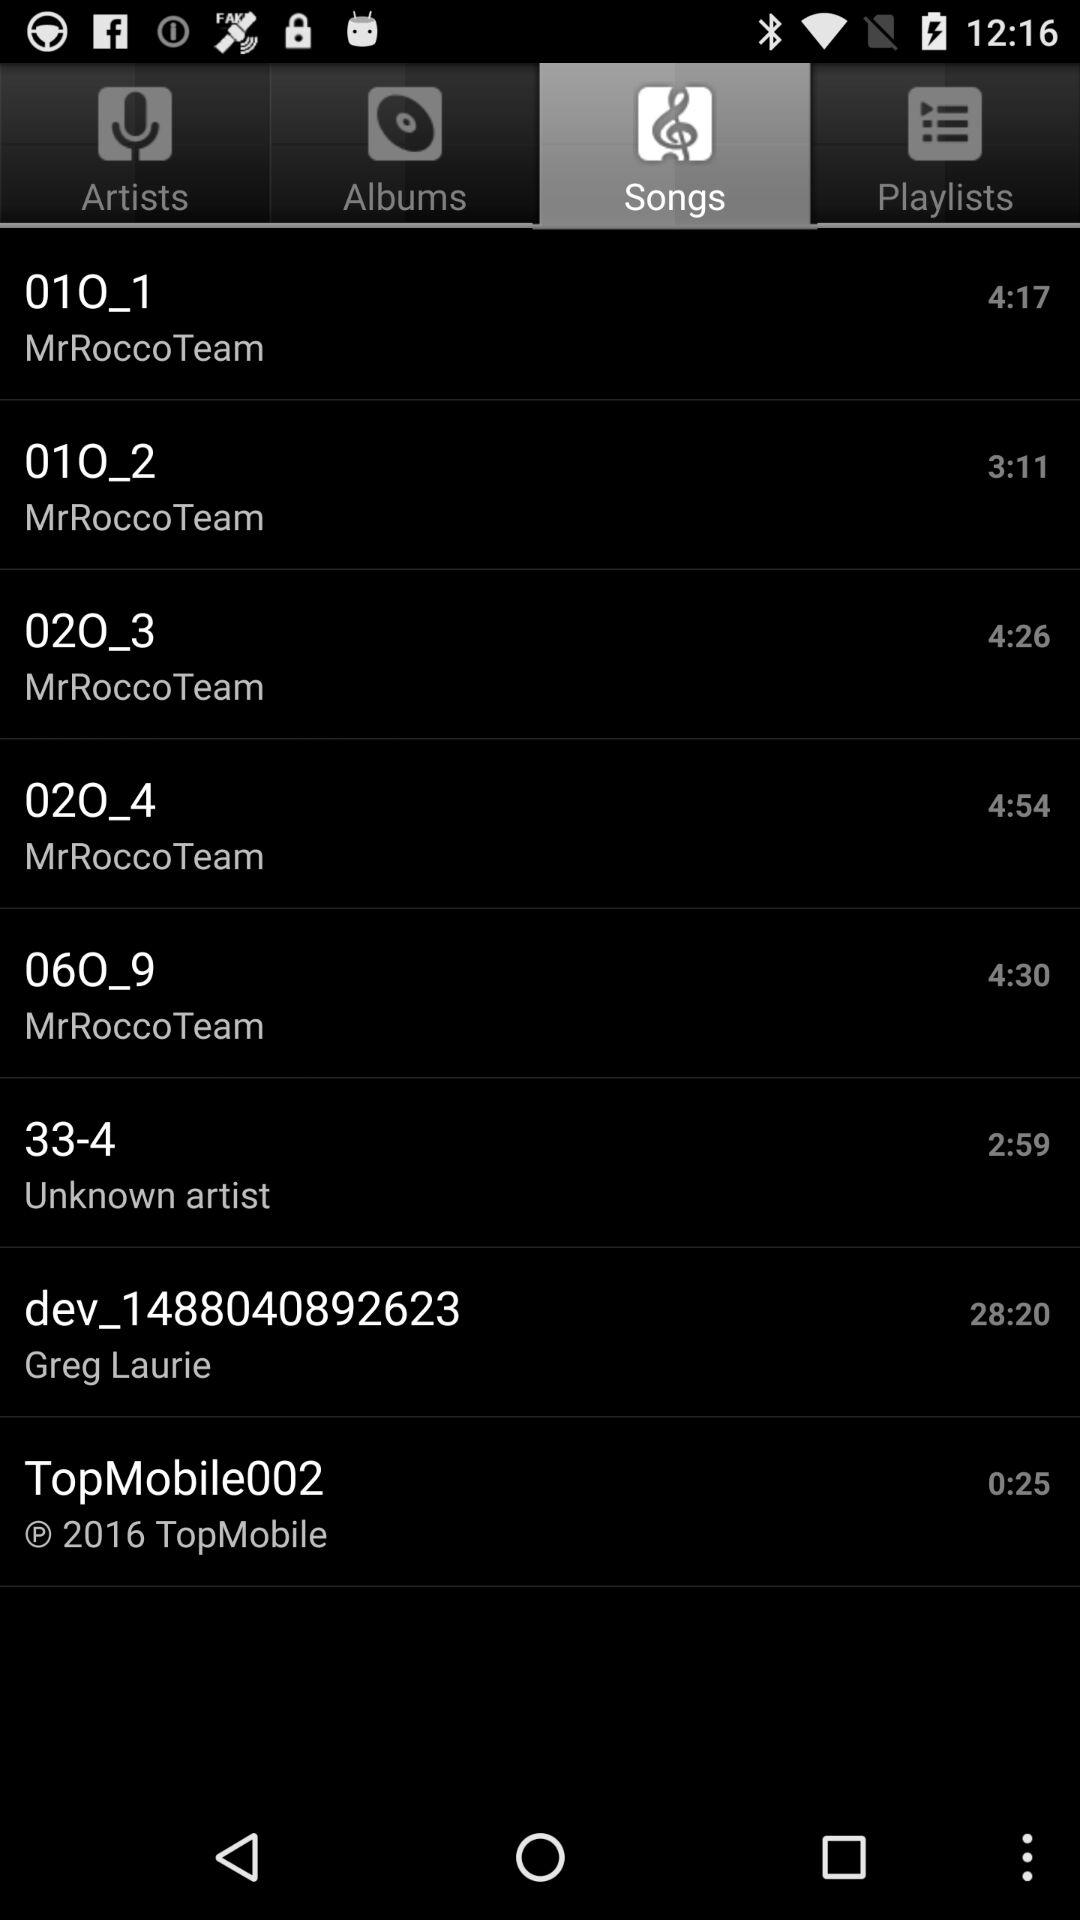What is the name of the song that lasts for 4 minutes and 17 seconds? The name of the song is "01O_1". 